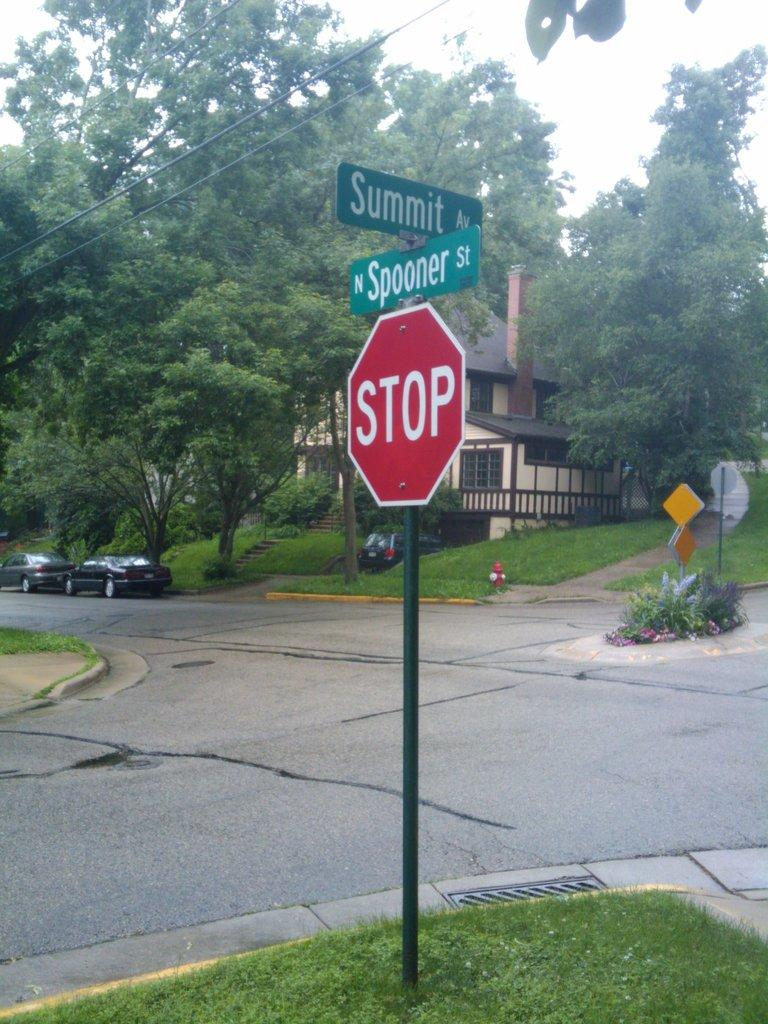<image>
Share a concise interpretation of the image provided. an intersection of two streets, summit and spooner st 